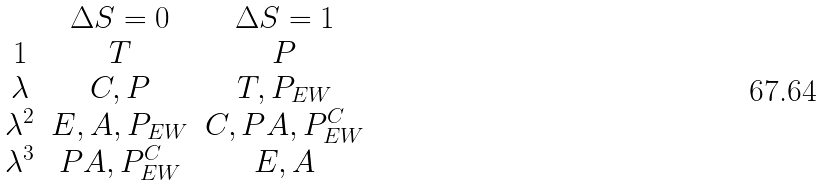<formula> <loc_0><loc_0><loc_500><loc_500>\begin{array} { c c c } & \Delta S = 0 & \Delta S = 1 \\ 1 & T & P \\ \lambda & C , P & T , P _ { E W } \\ \lambda ^ { 2 } & E , A , P _ { E W } & C , P A , P ^ { C } _ { E W } \\ \lambda ^ { 3 } & P A , P ^ { C } _ { E W } & E , A \end{array}</formula> 